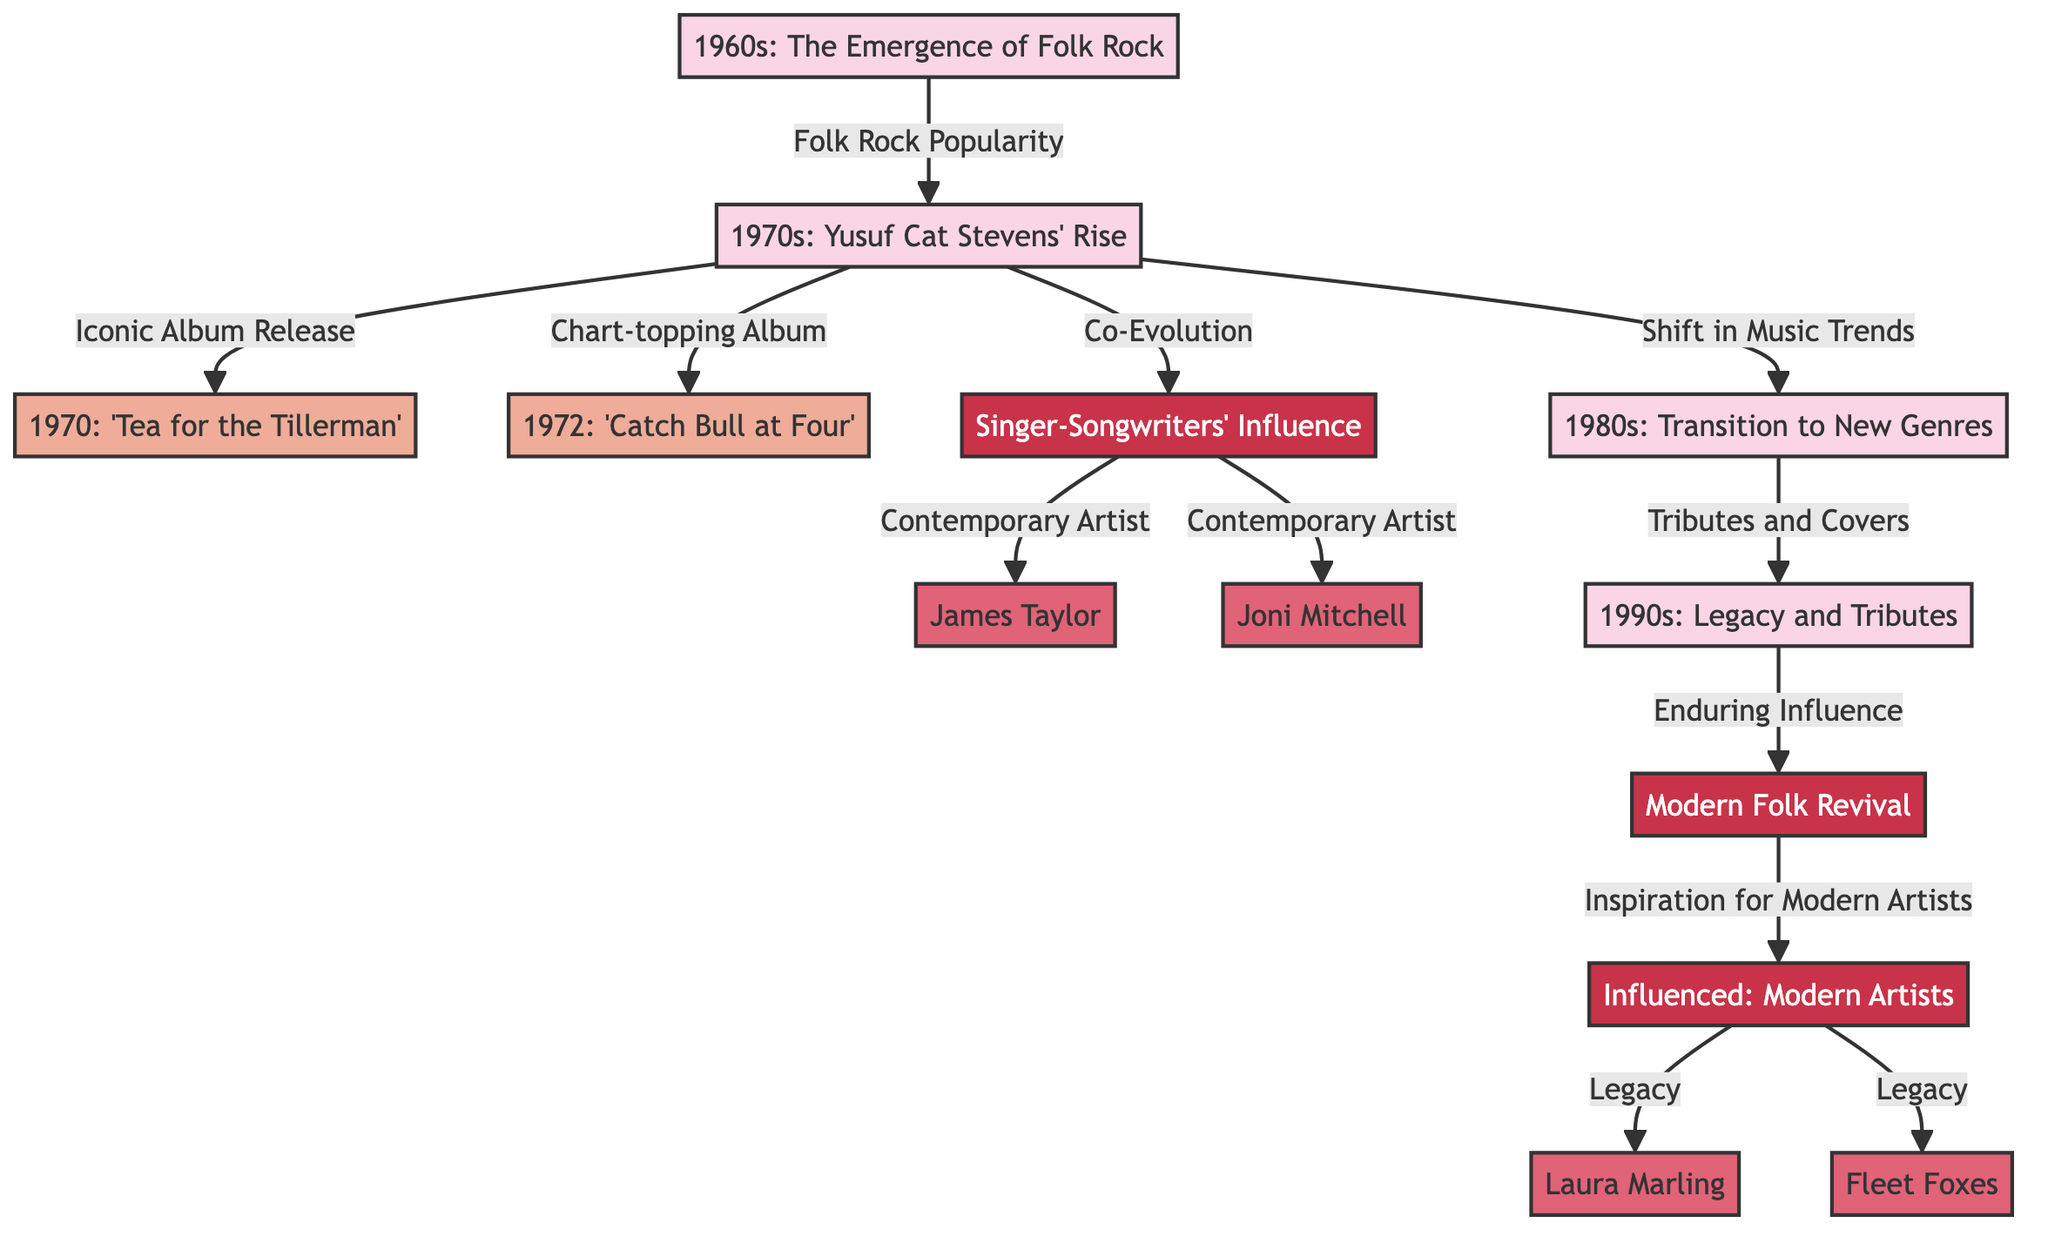What decade saw the emergence of Folk Rock? The diagram indicates that the 1960s is the decade marked with the emergence of Folk Rock, which is clearly labeled in the diagram.
Answer: 1960s Which album was released in 1970? The diagram specifies 'Tea for the Tillerman' as the album released in 1970, making it easy to identify this specific detail directly from the node.
Answer: 'Tea for the Tillerman' What is the relationship between the 1970s and the album 'Catch Bull at Four'? The diagram shows a directed edge from the 1970s node to 'Catch Bull at Four', indicating that it was a chart-topping album released during the 1970s.
Answer: Chart-topping Album Who are the two artists connected to the Troubadour influence? The diagram lists James Taylor and Joni Mitchell as artists influenced by the Troubadour era, indicating their connection directly through the arrows pointing towards them.
Answer: James Taylor, Joni Mitchell How many decades are represented in the diagram? By counting the decade nodes in the diagram, we can identify that there are five decades represented, which can be directly counted from the flowchart.
Answer: 5 What decade followed the 1970s in music evolution? The diagram illustrates that the 1970s leads into the 1980s, indicating that the transition occurred after the 1970s period in music history.
Answer: 1980s What modern genre emerged as a result of the 1990s? The diagram shows the connection from the 1990s to the Contemporary era, indicating that the modern folk revival emerged as a continuation of the legacy from the 1990s.
Answer: Modern Folk Revival Which artists were influenced by the legacy of Yusuf Cat Stevens according to the diagram? The diagram directly lists Laura Marling and Fleet Foxes as artists influenced by the legacy of Yusuf Cat Stevens, evidenced by the arrows connecting them to the Influenced Artists node.
Answer: Laura Marling, Fleet Foxes What era marked the shift in music trends leading to the 1980s? The diagram represents the 1970s as the period that transitioned to the 1980s, showcasing a shift in music trends as indicated by an arrow connecting them.
Answer: 1970s 